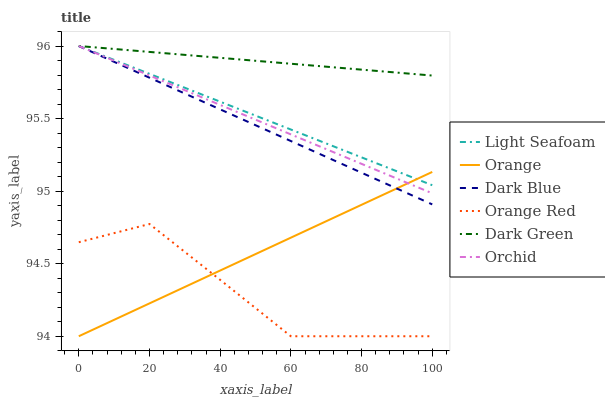Does Orange Red have the minimum area under the curve?
Answer yes or no. Yes. Does Dark Green have the maximum area under the curve?
Answer yes or no. Yes. Does Dark Blue have the minimum area under the curve?
Answer yes or no. No. Does Dark Blue have the maximum area under the curve?
Answer yes or no. No. Is Dark Green the smoothest?
Answer yes or no. Yes. Is Orange Red the roughest?
Answer yes or no. Yes. Is Dark Blue the smoothest?
Answer yes or no. No. Is Dark Blue the roughest?
Answer yes or no. No. Does Orange have the lowest value?
Answer yes or no. Yes. Does Dark Blue have the lowest value?
Answer yes or no. No. Does Orchid have the highest value?
Answer yes or no. Yes. Does Orange have the highest value?
Answer yes or no. No. Is Orange Red less than Dark Green?
Answer yes or no. Yes. Is Dark Green greater than Orange Red?
Answer yes or no. Yes. Does Dark Green intersect Dark Blue?
Answer yes or no. Yes. Is Dark Green less than Dark Blue?
Answer yes or no. No. Is Dark Green greater than Dark Blue?
Answer yes or no. No. Does Orange Red intersect Dark Green?
Answer yes or no. No. 